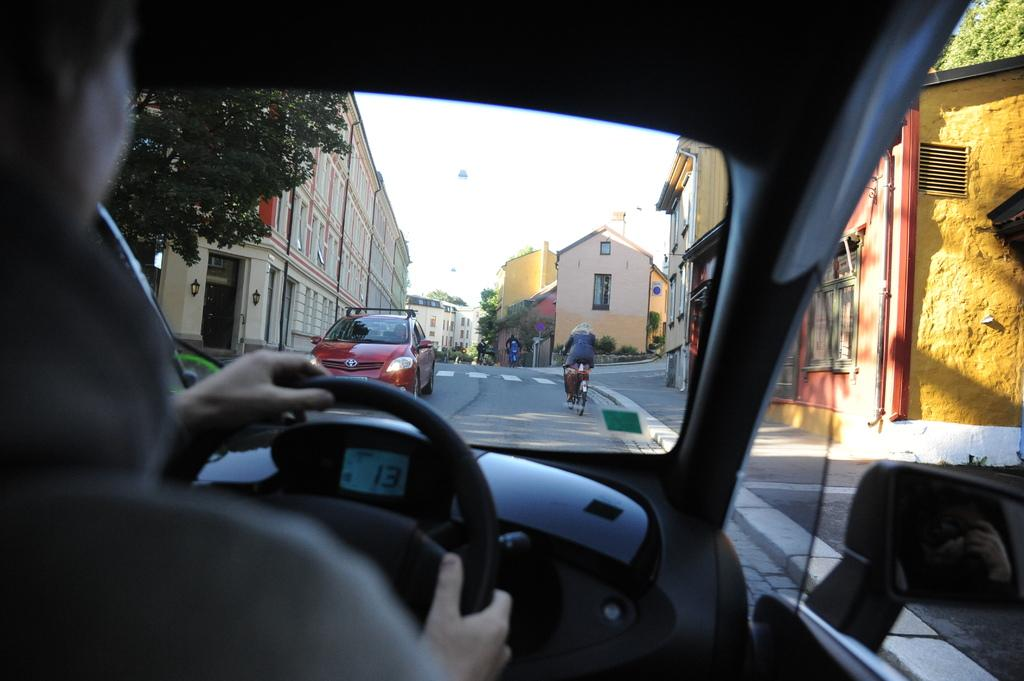What types of transportation can be seen on the road in the image? There are vehicles and bicycles on the road in the image. Can you describe the person in the image? A person is sitting in a vehicle in the image. What can be seen in the background of the image? There are trees, buildings, and the sky visible in the background of the image. What type of collar can be seen on the goose in the image? There is no goose present in the image, so there is no collar to be seen. 